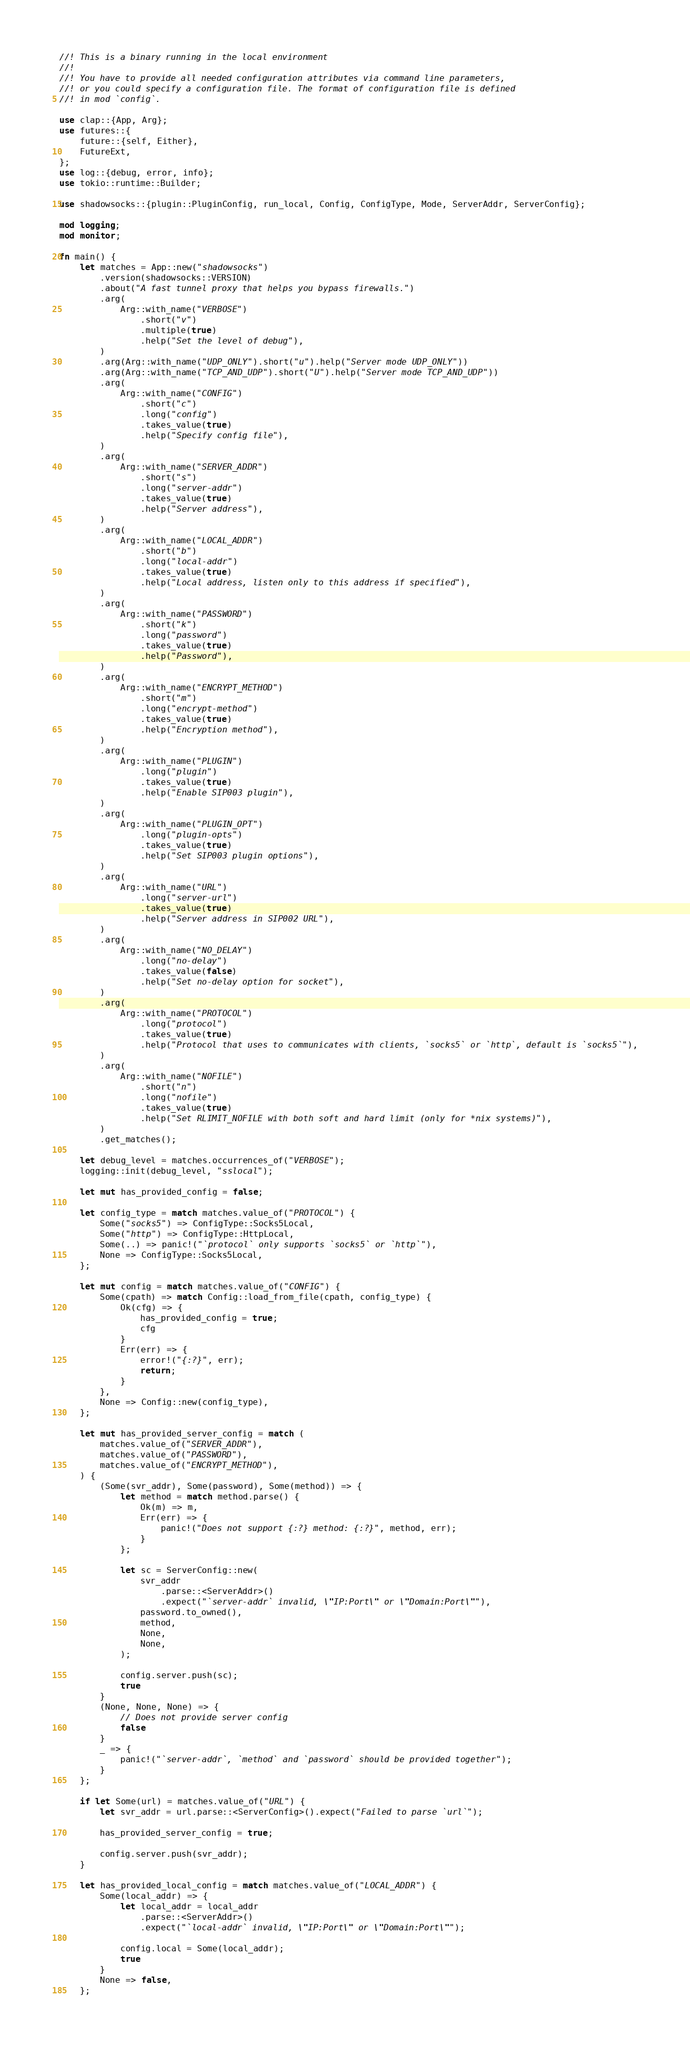Convert code to text. <code><loc_0><loc_0><loc_500><loc_500><_Rust_>//! This is a binary running in the local environment
//!
//! You have to provide all needed configuration attributes via command line parameters,
//! or you could specify a configuration file. The format of configuration file is defined
//! in mod `config`.

use clap::{App, Arg};
use futures::{
    future::{self, Either},
    FutureExt,
};
use log::{debug, error, info};
use tokio::runtime::Builder;

use shadowsocks::{plugin::PluginConfig, run_local, Config, ConfigType, Mode, ServerAddr, ServerConfig};

mod logging;
mod monitor;

fn main() {
    let matches = App::new("shadowsocks")
        .version(shadowsocks::VERSION)
        .about("A fast tunnel proxy that helps you bypass firewalls.")
        .arg(
            Arg::with_name("VERBOSE")
                .short("v")
                .multiple(true)
                .help("Set the level of debug"),
        )
        .arg(Arg::with_name("UDP_ONLY").short("u").help("Server mode UDP_ONLY"))
        .arg(Arg::with_name("TCP_AND_UDP").short("U").help("Server mode TCP_AND_UDP"))
        .arg(
            Arg::with_name("CONFIG")
                .short("c")
                .long("config")
                .takes_value(true)
                .help("Specify config file"),
        )
        .arg(
            Arg::with_name("SERVER_ADDR")
                .short("s")
                .long("server-addr")
                .takes_value(true)
                .help("Server address"),
        )
        .arg(
            Arg::with_name("LOCAL_ADDR")
                .short("b")
                .long("local-addr")
                .takes_value(true)
                .help("Local address, listen only to this address if specified"),
        )
        .arg(
            Arg::with_name("PASSWORD")
                .short("k")
                .long("password")
                .takes_value(true)
                .help("Password"),
        )
        .arg(
            Arg::with_name("ENCRYPT_METHOD")
                .short("m")
                .long("encrypt-method")
                .takes_value(true)
                .help("Encryption method"),
        )
        .arg(
            Arg::with_name("PLUGIN")
                .long("plugin")
                .takes_value(true)
                .help("Enable SIP003 plugin"),
        )
        .arg(
            Arg::with_name("PLUGIN_OPT")
                .long("plugin-opts")
                .takes_value(true)
                .help("Set SIP003 plugin options"),
        )
        .arg(
            Arg::with_name("URL")
                .long("server-url")
                .takes_value(true)
                .help("Server address in SIP002 URL"),
        )
        .arg(
            Arg::with_name("NO_DELAY")
                .long("no-delay")
                .takes_value(false)
                .help("Set no-delay option for socket"),
        )
        .arg(
            Arg::with_name("PROTOCOL")
                .long("protocol")
                .takes_value(true)
                .help("Protocol that uses to communicates with clients, `socks5` or `http`, default is `socks5`"),
        )
        .arg(
            Arg::with_name("NOFILE")
                .short("n")
                .long("nofile")
                .takes_value(true)
                .help("Set RLIMIT_NOFILE with both soft and hard limit (only for *nix systems)"),
        )
        .get_matches();

    let debug_level = matches.occurrences_of("VERBOSE");
    logging::init(debug_level, "sslocal");

    let mut has_provided_config = false;

    let config_type = match matches.value_of("PROTOCOL") {
        Some("socks5") => ConfigType::Socks5Local,
        Some("http") => ConfigType::HttpLocal,
        Some(..) => panic!("`protocol` only supports `socks5` or `http`"),
        None => ConfigType::Socks5Local,
    };

    let mut config = match matches.value_of("CONFIG") {
        Some(cpath) => match Config::load_from_file(cpath, config_type) {
            Ok(cfg) => {
                has_provided_config = true;
                cfg
            }
            Err(err) => {
                error!("{:?}", err);
                return;
            }
        },
        None => Config::new(config_type),
    };

    let mut has_provided_server_config = match (
        matches.value_of("SERVER_ADDR"),
        matches.value_of("PASSWORD"),
        matches.value_of("ENCRYPT_METHOD"),
    ) {
        (Some(svr_addr), Some(password), Some(method)) => {
            let method = match method.parse() {
                Ok(m) => m,
                Err(err) => {
                    panic!("Does not support {:?} method: {:?}", method, err);
                }
            };

            let sc = ServerConfig::new(
                svr_addr
                    .parse::<ServerAddr>()
                    .expect("`server-addr` invalid, \"IP:Port\" or \"Domain:Port\""),
                password.to_owned(),
                method,
                None,
                None,
            );

            config.server.push(sc);
            true
        }
        (None, None, None) => {
            // Does not provide server config
            false
        }
        _ => {
            panic!("`server-addr`, `method` and `password` should be provided together");
        }
    };

    if let Some(url) = matches.value_of("URL") {
        let svr_addr = url.parse::<ServerConfig>().expect("Failed to parse `url`");

        has_provided_server_config = true;

        config.server.push(svr_addr);
    }

    let has_provided_local_config = match matches.value_of("LOCAL_ADDR") {
        Some(local_addr) => {
            let local_addr = local_addr
                .parse::<ServerAddr>()
                .expect("`local-addr` invalid, \"IP:Port\" or \"Domain:Port\"");

            config.local = Some(local_addr);
            true
        }
        None => false,
    };
</code> 